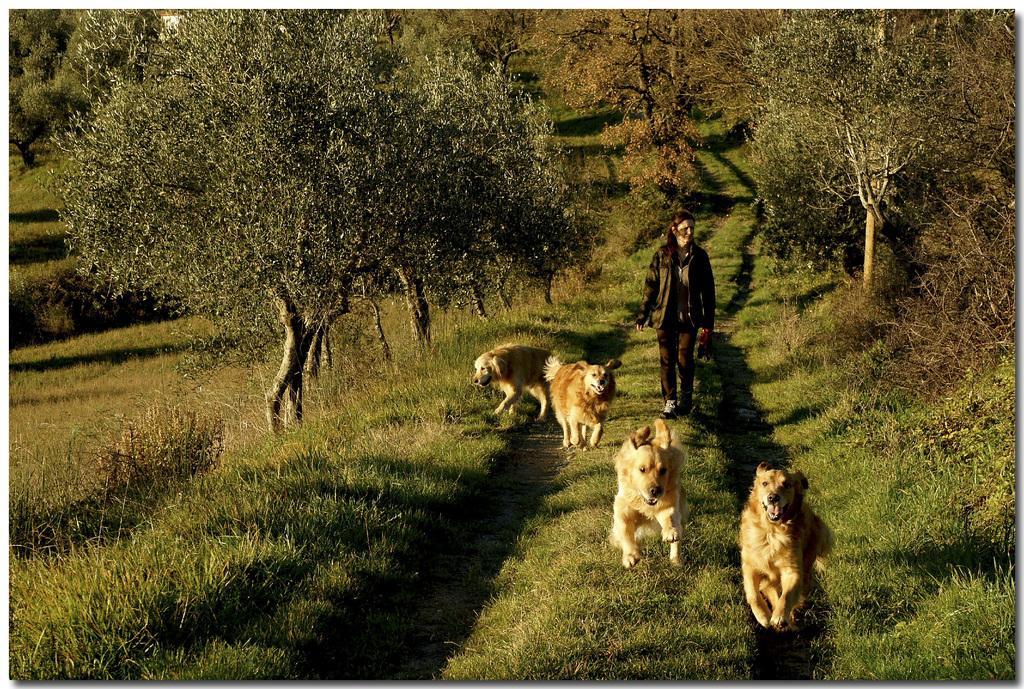In one or two sentences, can you explain what this image depicts? Here in this picture we can see a group of dogs running in a field, which is totally covered with grass over there and we can see a woman also walking on the field over there and we can see plants and trees present all over there. 